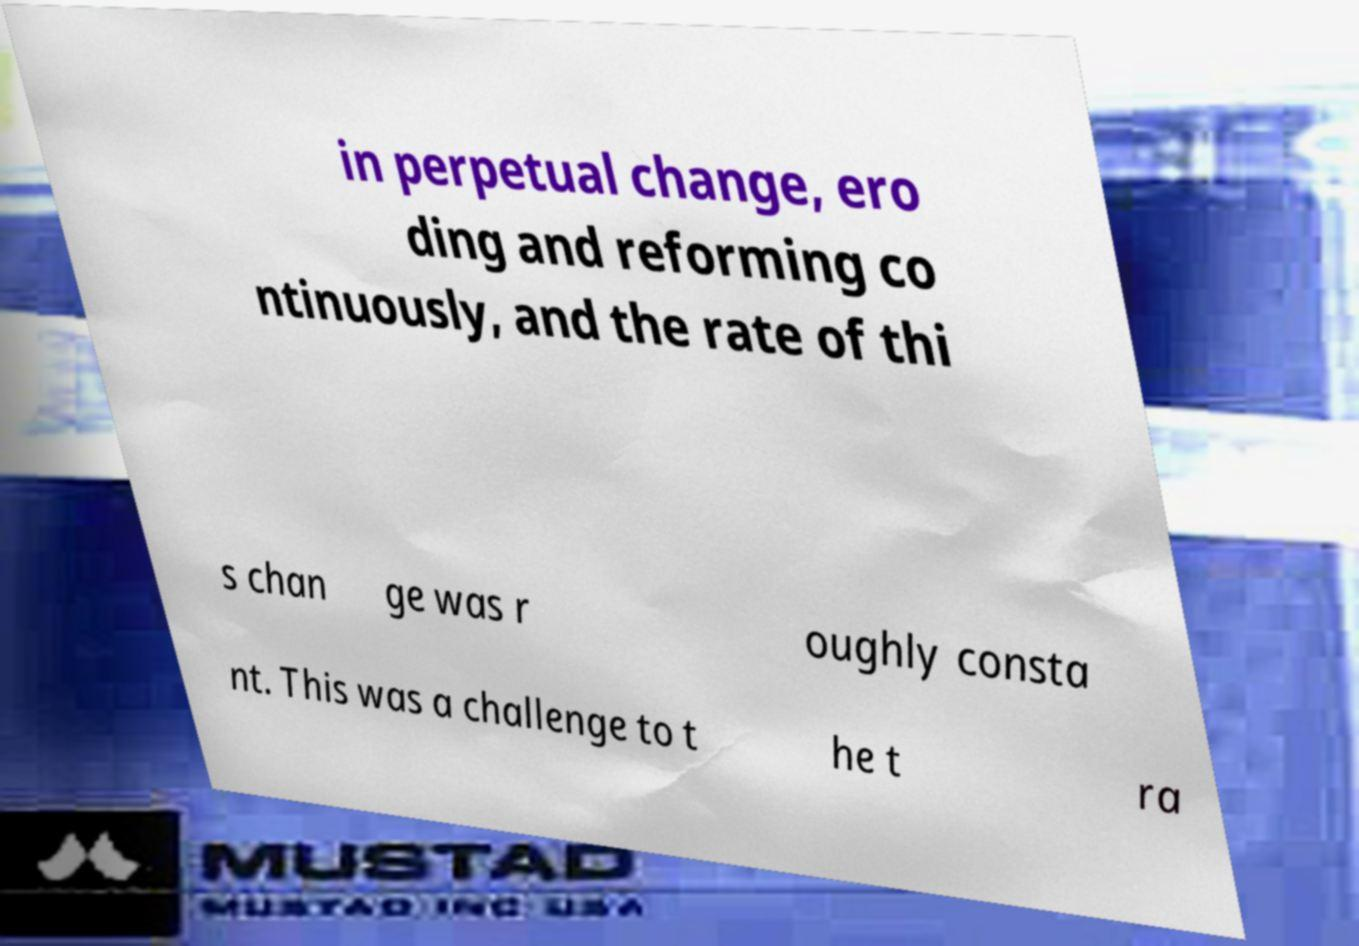Can you accurately transcribe the text from the provided image for me? in perpetual change, ero ding and reforming co ntinuously, and the rate of thi s chan ge was r oughly consta nt. This was a challenge to t he t ra 